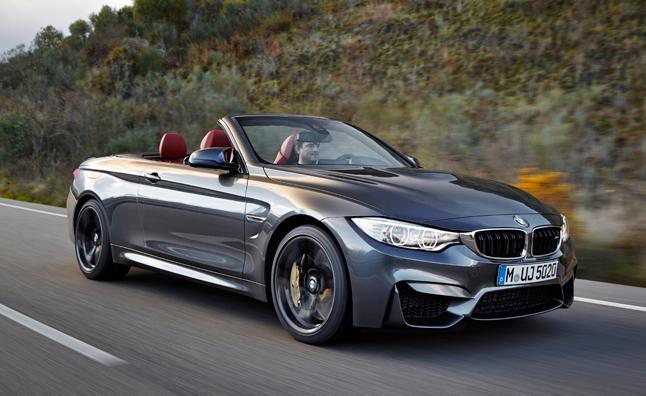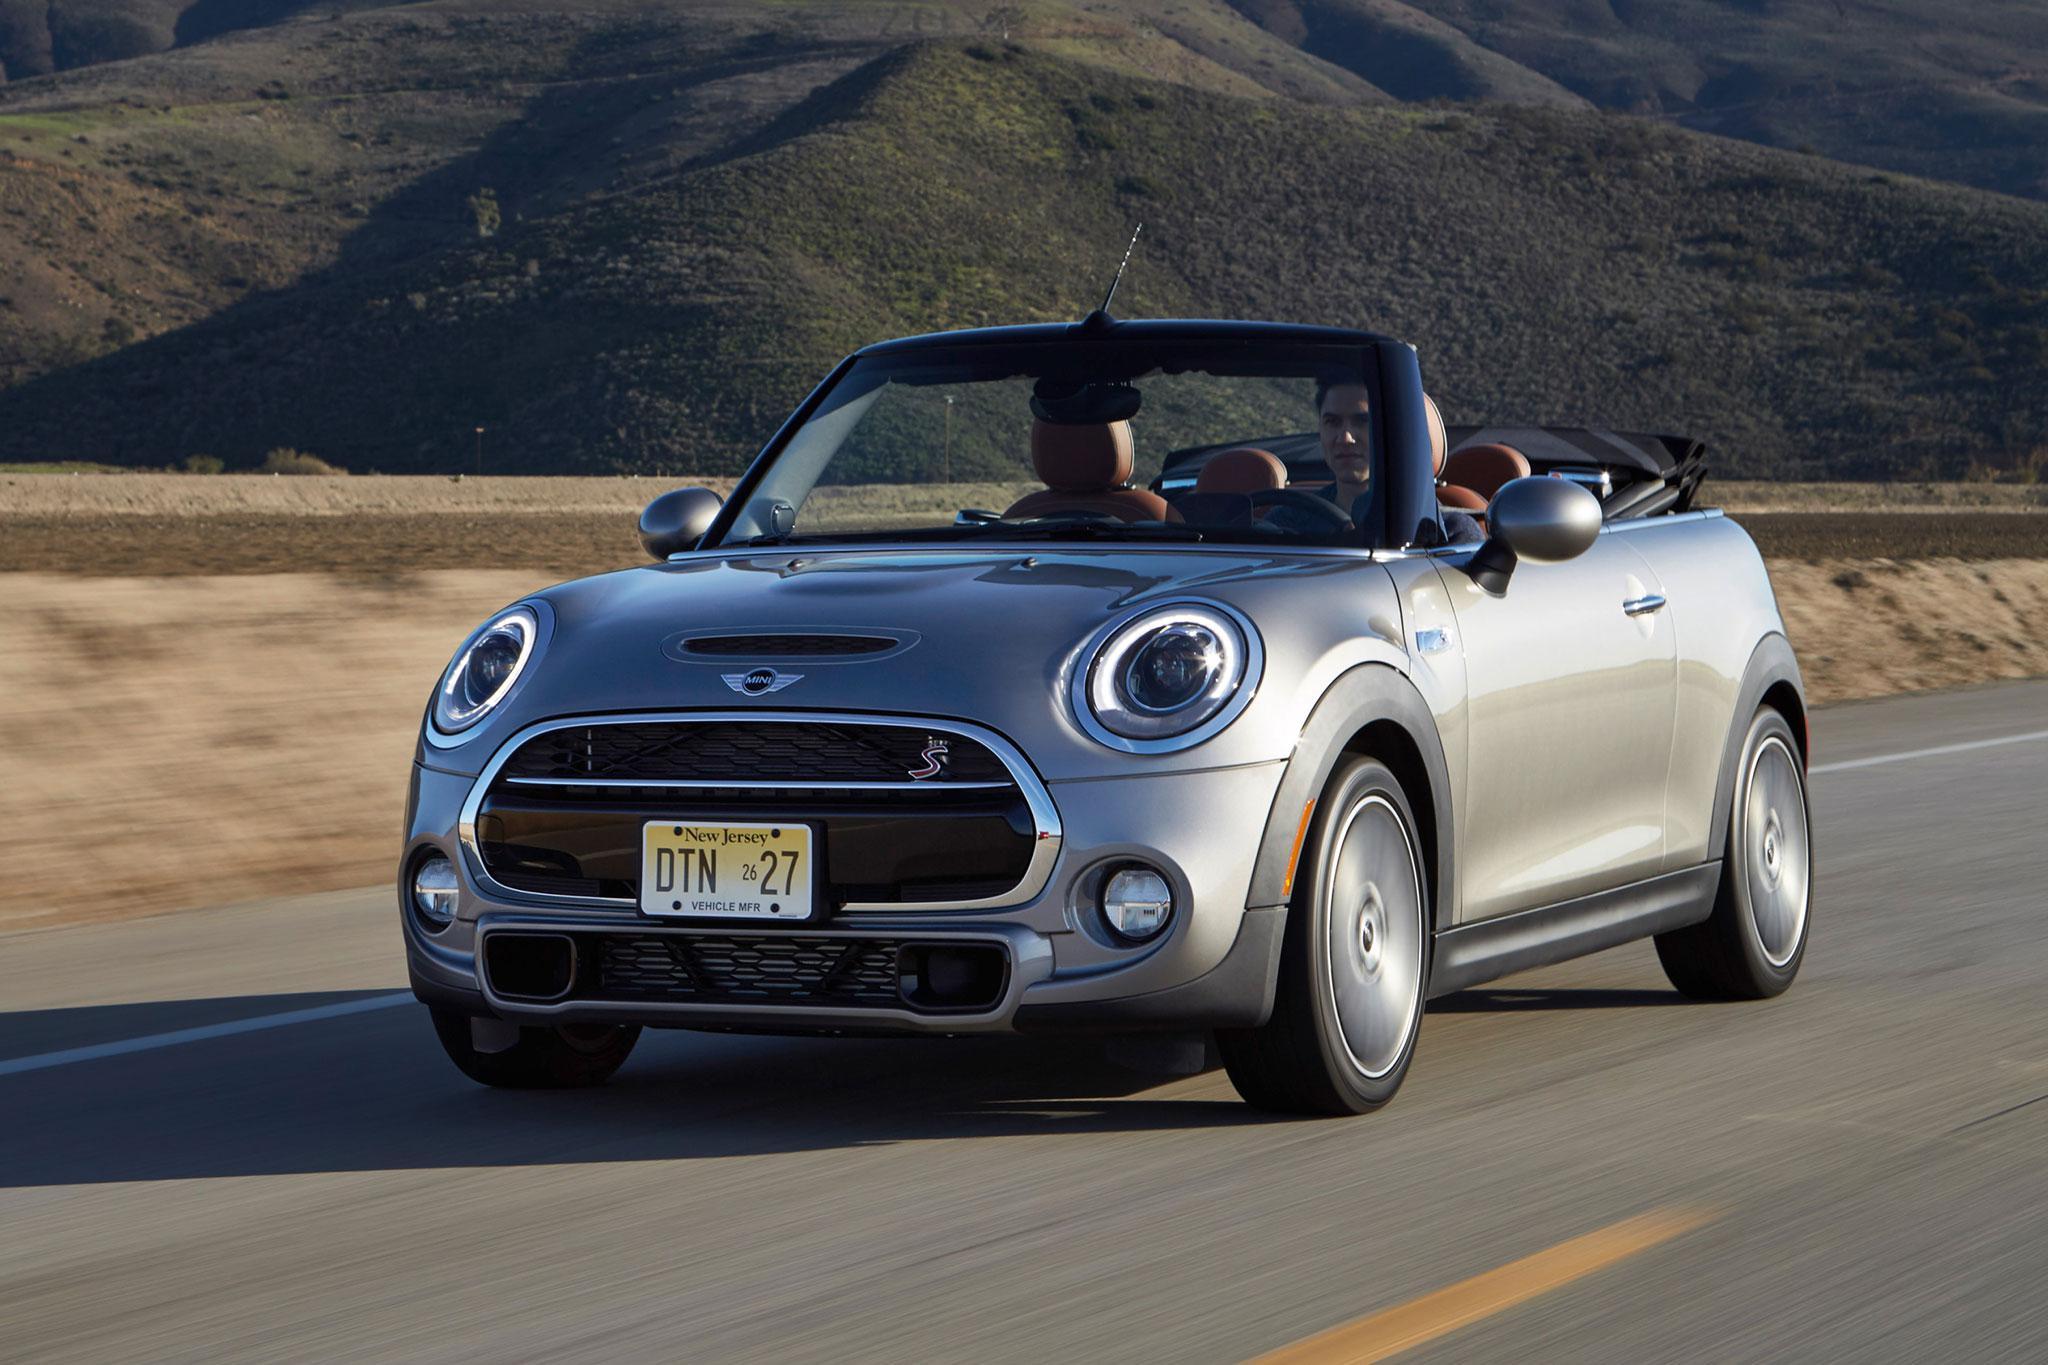The first image is the image on the left, the second image is the image on the right. For the images shown, is this caption "The silver convertibles in these images are currently being driven and are not parked." true? Answer yes or no. Yes. The first image is the image on the left, the second image is the image on the right. Given the left and right images, does the statement "Each image contains one forward-angled car with its top down and a driver behind the wheel." hold true? Answer yes or no. Yes. 